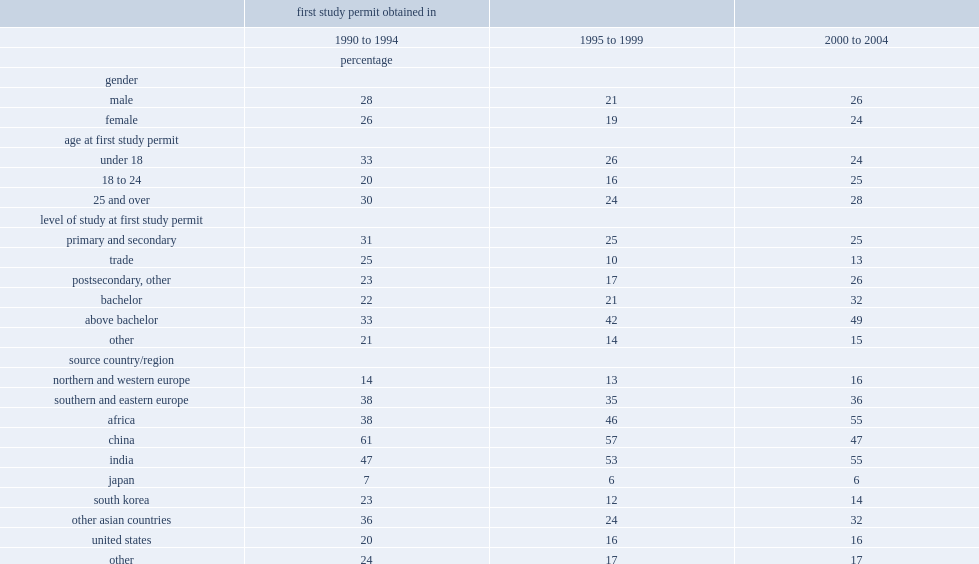Within all cohorts, what is the margin between male international students and female international students in transition rates? 2. Among the early 1990s- cohorts, which age group has the lowest transition rates among international students who first obtained their study permit? 18 to 24. Among the late-1990s cohorts, which age group has the lowest transition rates among international students who first obtained their study permit? 18 to 24. Within the early 2000s cohorts, what is the transition rates between those ages under 18? 24.0. Within the early 2000s cohorts, what is the transition rates between those ages of 25 and over? 28.0. Among the early 1990s cohorts, what is the transition rate among international students who came to canada to study at the bachelor level? 22.0. Among the early 2000s cohorts, what is the transition rate among international students who came to canada to study at the bachelor level? 32.0. 